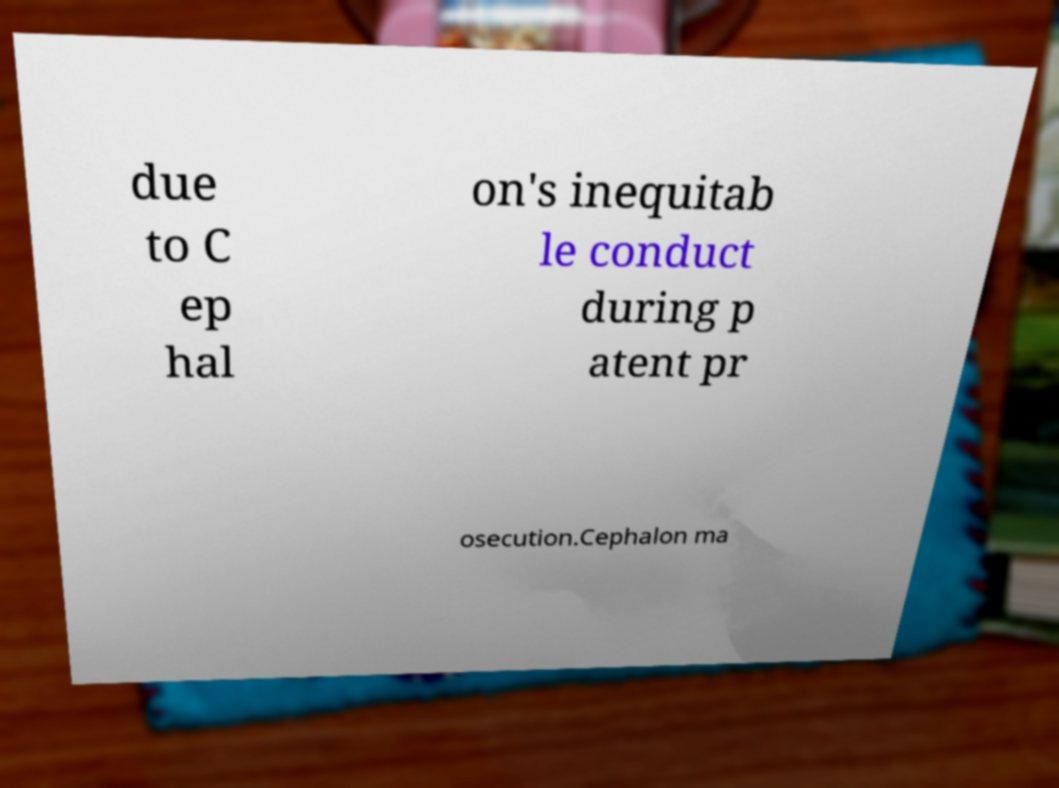Could you extract and type out the text from this image? due to C ep hal on's inequitab le conduct during p atent pr osecution.Cephalon ma 